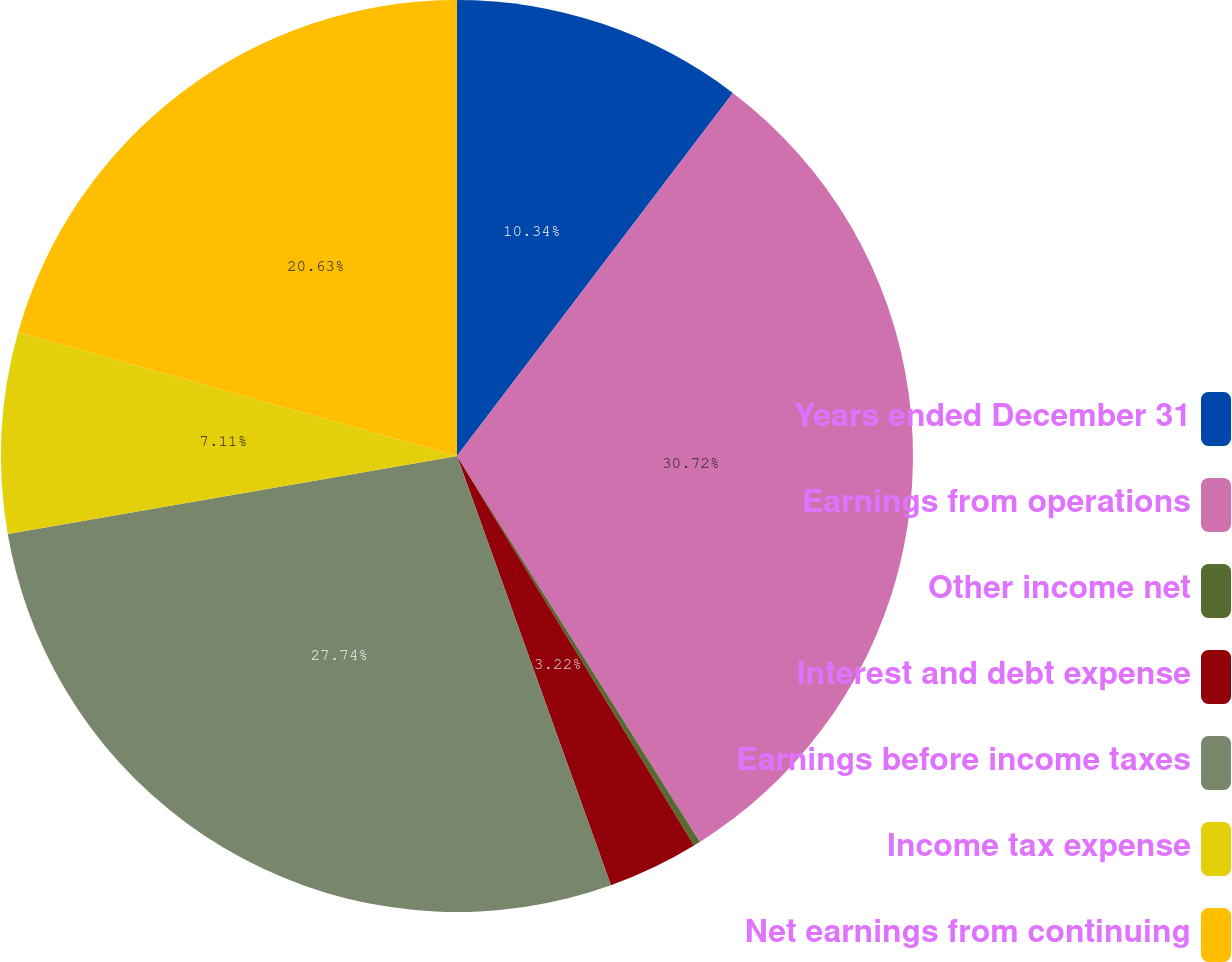Convert chart. <chart><loc_0><loc_0><loc_500><loc_500><pie_chart><fcel>Years ended December 31<fcel>Earnings from operations<fcel>Other income net<fcel>Interest and debt expense<fcel>Earnings before income taxes<fcel>Income tax expense<fcel>Net earnings from continuing<nl><fcel>10.34%<fcel>30.72%<fcel>0.24%<fcel>3.22%<fcel>27.74%<fcel>7.11%<fcel>20.63%<nl></chart> 